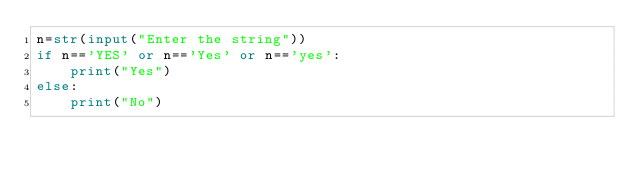<code> <loc_0><loc_0><loc_500><loc_500><_Python_>n=str(input("Enter the string"))
if n=='YES' or n=='Yes' or n=='yes':
    print("Yes")
else:
    print("No")
</code> 